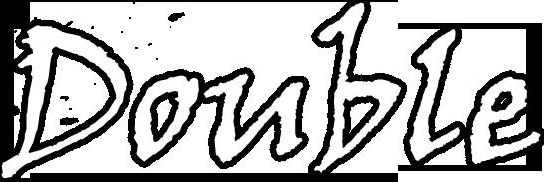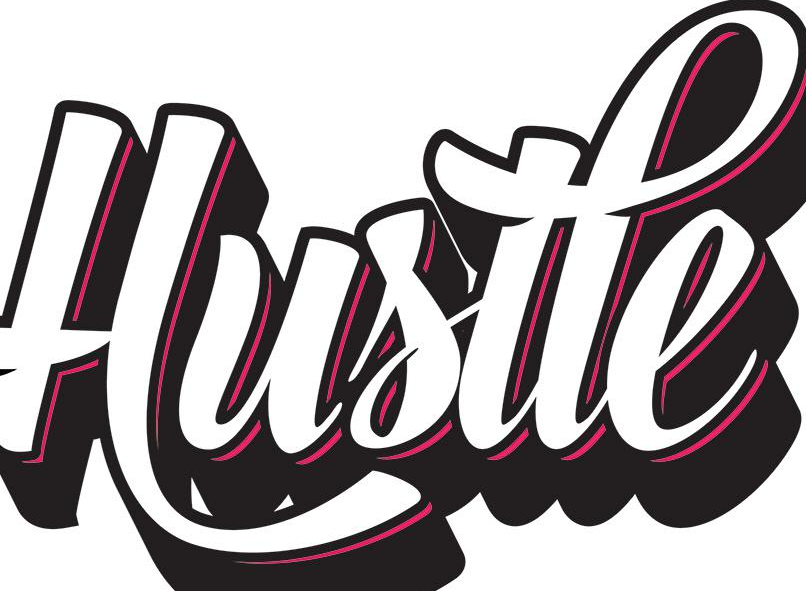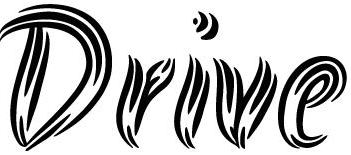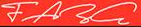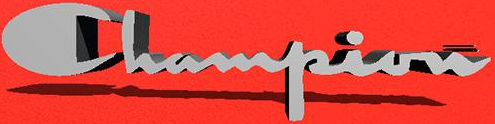What words can you see in these images in sequence, separated by a semicolon? Double; Hustle; Drive; FARG; Champion 